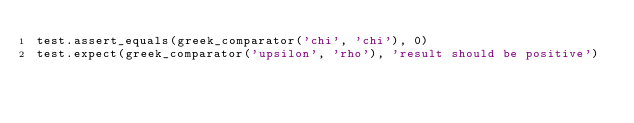<code> <loc_0><loc_0><loc_500><loc_500><_Python_>test.assert_equals(greek_comparator('chi', 'chi'), 0)
test.expect(greek_comparator('upsilon', 'rho'), 'result should be positive')
</code> 